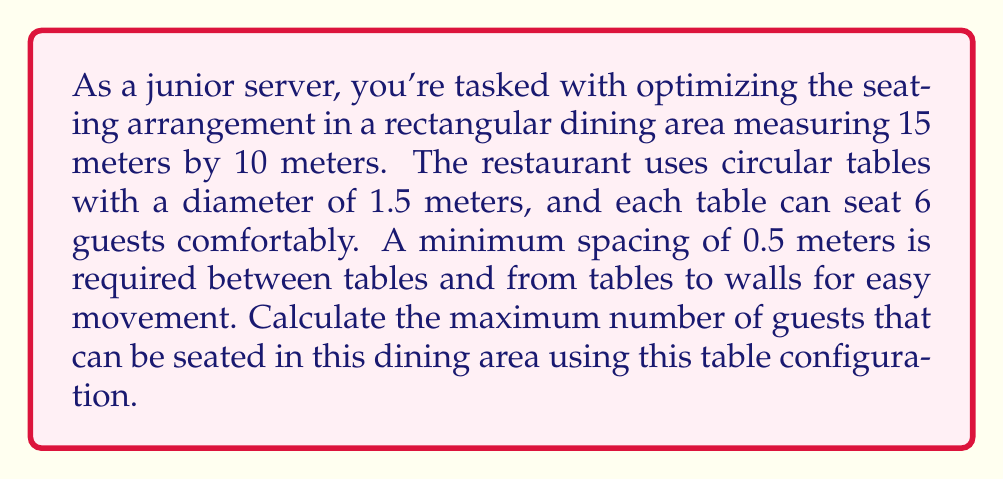Show me your answer to this math problem. Let's approach this step-by-step:

1) First, we need to calculate the effective area where tables can be placed:
   - Length: $15 - (2 \times 0.5) = 14$ meters
   - Width: $10 - (2 \times 0.5) = 9$ meters
   Effective area: $14 \times 9 = 126$ m²

2) Now, let's calculate the area occupied by each table, including the required spacing:
   - Table diameter: 1.5 m
   - Required spacing: 0.5 m on each side
   - Total diameter with spacing: $1.5 + (2 \times 0.5) = 2.5$ m
   - Area per table: $\pi r^2 = \pi (1.25)^2 \approx 4.91$ m²

3) To find the maximum number of tables, we divide the effective area by the area per table:
   $\text{Number of tables} = \lfloor \frac{126}{4.91} \rfloor = 25$ (rounded down)

4) Each table can seat 6 guests, so the maximum number of guests is:
   $\text{Maximum guests} = 25 \times 6 = 150$

[asy]
unitsize(10cm);
draw((0,0)--(1.4,0)--(1.4,0.9)--(0,0.9)--cycle);
for(int i=0; i<5; ++i)
  for(int j=0; j<5; ++j)
    draw(circle((0.14+0.28*i,0.09+0.18*j),0.075));
label("15m", (0.7,-0.05));
label("10m", (1.45,0.45), E);
[/asy]

The diagram above illustrates a possible arrangement of 25 tables in the dining area.
Answer: 150 guests 